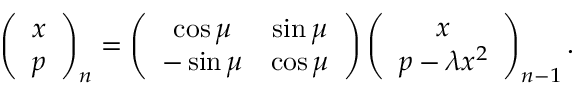<formula> <loc_0><loc_0><loc_500><loc_500>\left ( \begin{array} { c } { x } \\ { p } \end{array} \right ) _ { n } = \left ( \begin{array} { c c } { \cos \mu } & { \sin \mu } \\ { - \sin \mu } & { \cos \mu } \end{array} \right ) \left ( \begin{array} { c } { x } \\ { p - \lambda x ^ { 2 } } \end{array} \right ) _ { n - 1 } .</formula> 